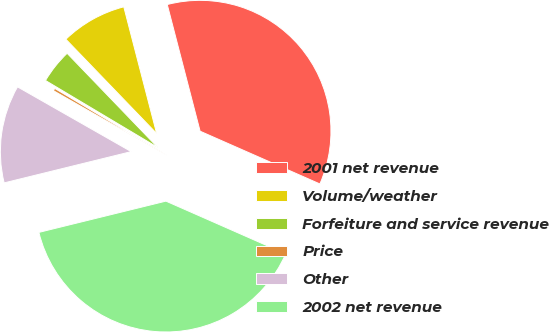<chart> <loc_0><loc_0><loc_500><loc_500><pie_chart><fcel>2001 net revenue<fcel>Volume/weather<fcel>Forfeiture and service revenue<fcel>Price<fcel>Other<fcel>2002 net revenue<nl><fcel>35.64%<fcel>8.16%<fcel>4.24%<fcel>0.32%<fcel>12.08%<fcel>39.56%<nl></chart> 